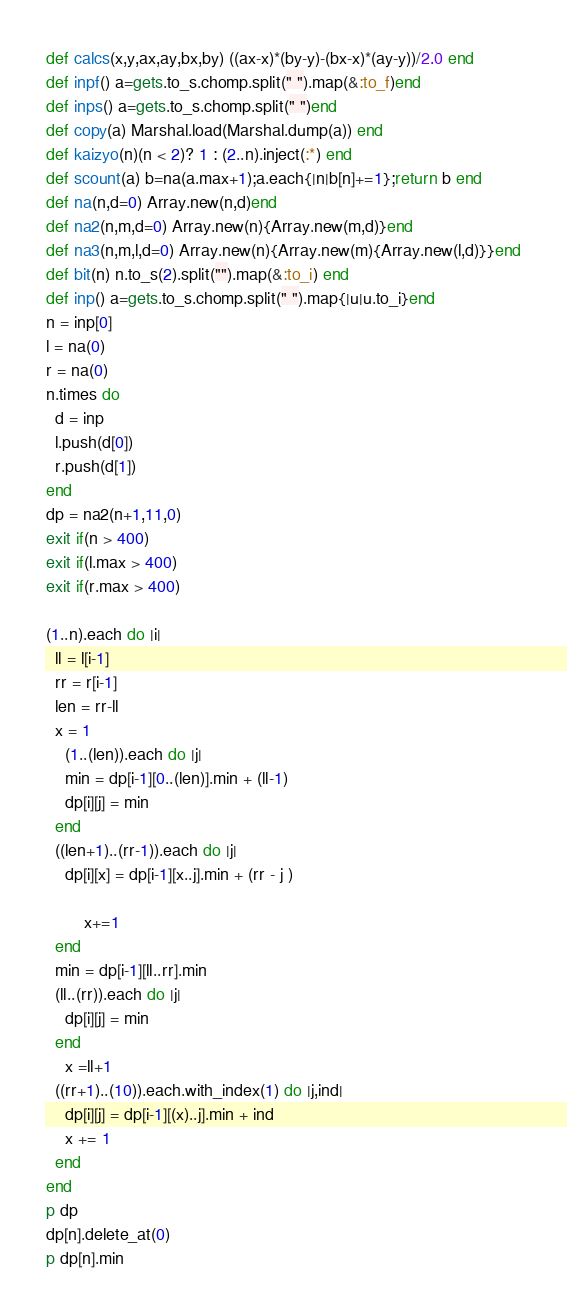<code> <loc_0><loc_0><loc_500><loc_500><_Crystal_>def calcs(x,y,ax,ay,bx,by) ((ax-x)*(by-y)-(bx-x)*(ay-y))/2.0 end
def inpf() a=gets.to_s.chomp.split(" ").map(&:to_f)end
def inps() a=gets.to_s.chomp.split(" ")end  
def copy(a) Marshal.load(Marshal.dump(a)) end
def kaizyo(n)(n < 2)? 1 : (2..n).inject(:*) end
def scount(a) b=na(a.max+1);a.each{|n|b[n]+=1};return b end
def na(n,d=0) Array.new(n,d)end
def na2(n,m,d=0) Array.new(n){Array.new(m,d)}end
def na3(n,m,l,d=0) Array.new(n){Array.new(m){Array.new(l,d)}}end
def bit(n) n.to_s(2).split("").map(&:to_i) end
def inp() a=gets.to_s.chomp.split(" ").map{|u|u.to_i}end
n = inp[0]
l = na(0)
r = na(0)
n.times do
  d = inp
  l.push(d[0])
  r.push(d[1])
end
dp = na2(n+1,11,0)
exit if(n > 400)
exit if(l.max > 400)
exit if(r.max > 400)

(1..n).each do |i|
  ll = l[i-1]
  rr = r[i-1]
  len = rr-ll
  x = 1
    (1..(len)).each do |j|
    min = dp[i-1][0..(len)].min + (ll-1)
    dp[i][j] = min
  end
  ((len+1)..(rr-1)).each do |j|
    dp[i][x] = dp[i-1][x..j].min + (rr - j )

        x+=1
  end
  min = dp[i-1][ll..rr].min
  (ll..(rr)).each do |j|
    dp[i][j] = min
  end
    x =ll+1
  ((rr+1)..(10)).each.with_index(1) do |j,ind|
    dp[i][j] = dp[i-1][(x)..j].min + ind
    x += 1
  end
end
p dp
dp[n].delete_at(0)
p dp[n].min</code> 